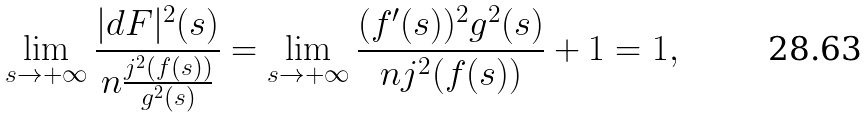Convert formula to latex. <formula><loc_0><loc_0><loc_500><loc_500>\lim _ { s \rightarrow + \infty } \frac { | d F | ^ { 2 } ( s ) } { n \frac { j ^ { 2 } ( f ( s ) ) } { g ^ { 2 } ( s ) } } = \lim _ { s \rightarrow + \infty } \frac { ( f ^ { \prime } ( s ) ) ^ { 2 } g ^ { 2 } ( s ) } { n j ^ { 2 } ( f ( s ) ) } + 1 = 1 ,</formula> 